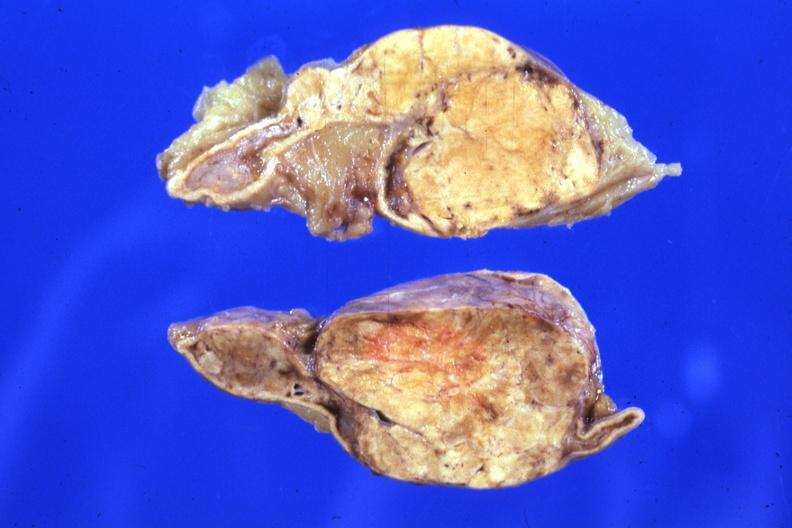what sectioned gland rather large lesion?
Answer the question using a single word or phrase. Fixed tissue 